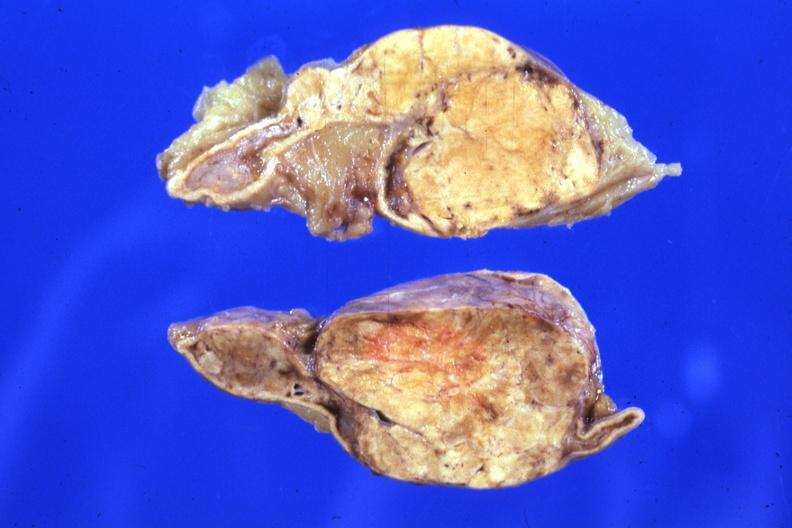what sectioned gland rather large lesion?
Answer the question using a single word or phrase. Fixed tissue 